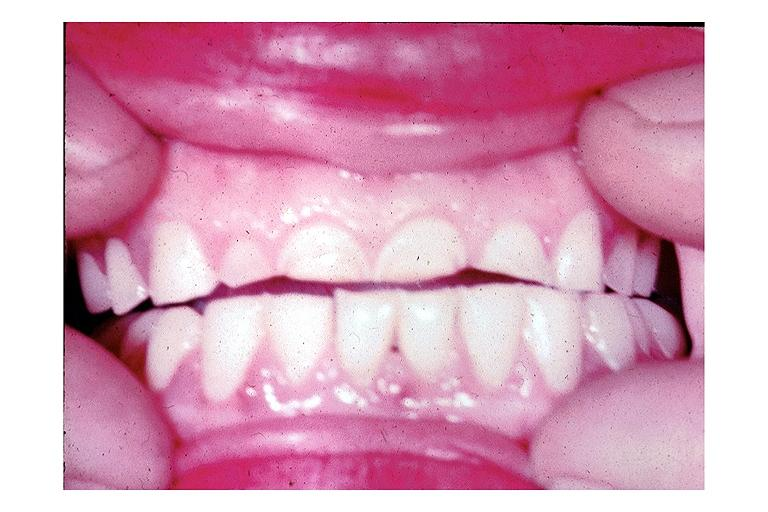what is present?
Answer the question using a single word or phrase. Oral 